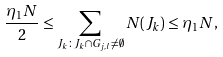Convert formula to latex. <formula><loc_0><loc_0><loc_500><loc_500>\frac { \eta _ { 1 } N } { 2 } \leq \sum _ { J _ { k } \colon J _ { k } \cap G _ { j , l } \neq \emptyset } N ( J _ { k } ) \leq \eta _ { 1 } N ,</formula> 